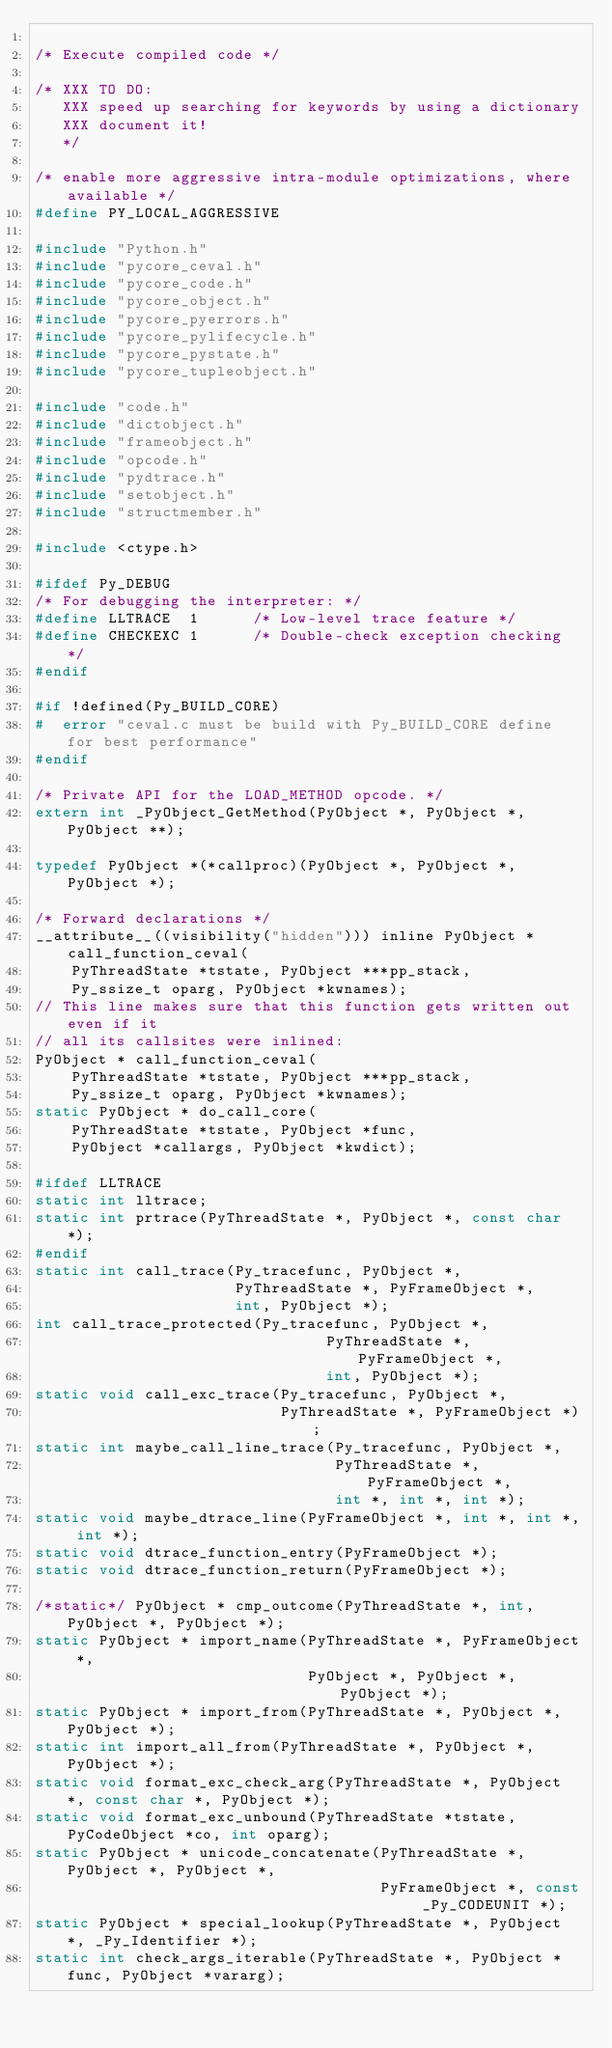<code> <loc_0><loc_0><loc_500><loc_500><_C_>
/* Execute compiled code */

/* XXX TO DO:
   XXX speed up searching for keywords by using a dictionary
   XXX document it!
   */

/* enable more aggressive intra-module optimizations, where available */
#define PY_LOCAL_AGGRESSIVE

#include "Python.h"
#include "pycore_ceval.h"
#include "pycore_code.h"
#include "pycore_object.h"
#include "pycore_pyerrors.h"
#include "pycore_pylifecycle.h"
#include "pycore_pystate.h"
#include "pycore_tupleobject.h"

#include "code.h"
#include "dictobject.h"
#include "frameobject.h"
#include "opcode.h"
#include "pydtrace.h"
#include "setobject.h"
#include "structmember.h"

#include <ctype.h>

#ifdef Py_DEBUG
/* For debugging the interpreter: */
#define LLTRACE  1      /* Low-level trace feature */
#define CHECKEXC 1      /* Double-check exception checking */
#endif

#if !defined(Py_BUILD_CORE)
#  error "ceval.c must be build with Py_BUILD_CORE define for best performance"
#endif

/* Private API for the LOAD_METHOD opcode. */
extern int _PyObject_GetMethod(PyObject *, PyObject *, PyObject **);

typedef PyObject *(*callproc)(PyObject *, PyObject *, PyObject *);

/* Forward declarations */
__attribute__((visibility("hidden"))) inline PyObject * call_function_ceval(
    PyThreadState *tstate, PyObject ***pp_stack,
    Py_ssize_t oparg, PyObject *kwnames);
// This line makes sure that this function gets written out even if it
// all its callsites were inlined:
PyObject * call_function_ceval(
    PyThreadState *tstate, PyObject ***pp_stack,
    Py_ssize_t oparg, PyObject *kwnames);
static PyObject * do_call_core(
    PyThreadState *tstate, PyObject *func,
    PyObject *callargs, PyObject *kwdict);

#ifdef LLTRACE
static int lltrace;
static int prtrace(PyThreadState *, PyObject *, const char *);
#endif
static int call_trace(Py_tracefunc, PyObject *,
                      PyThreadState *, PyFrameObject *,
                      int, PyObject *);
int call_trace_protected(Py_tracefunc, PyObject *,
                                PyThreadState *, PyFrameObject *,
                                int, PyObject *);
static void call_exc_trace(Py_tracefunc, PyObject *,
                           PyThreadState *, PyFrameObject *);
static int maybe_call_line_trace(Py_tracefunc, PyObject *,
                                 PyThreadState *, PyFrameObject *,
                                 int *, int *, int *);
static void maybe_dtrace_line(PyFrameObject *, int *, int *, int *);
static void dtrace_function_entry(PyFrameObject *);
static void dtrace_function_return(PyFrameObject *);

/*static*/ PyObject * cmp_outcome(PyThreadState *, int, PyObject *, PyObject *);
static PyObject * import_name(PyThreadState *, PyFrameObject *,
                              PyObject *, PyObject *, PyObject *);
static PyObject * import_from(PyThreadState *, PyObject *, PyObject *);
static int import_all_from(PyThreadState *, PyObject *, PyObject *);
static void format_exc_check_arg(PyThreadState *, PyObject *, const char *, PyObject *);
static void format_exc_unbound(PyThreadState *tstate, PyCodeObject *co, int oparg);
static PyObject * unicode_concatenate(PyThreadState *, PyObject *, PyObject *,
                                      PyFrameObject *, const _Py_CODEUNIT *);
static PyObject * special_lookup(PyThreadState *, PyObject *, _Py_Identifier *);
static int check_args_iterable(PyThreadState *, PyObject *func, PyObject *vararg);</code> 